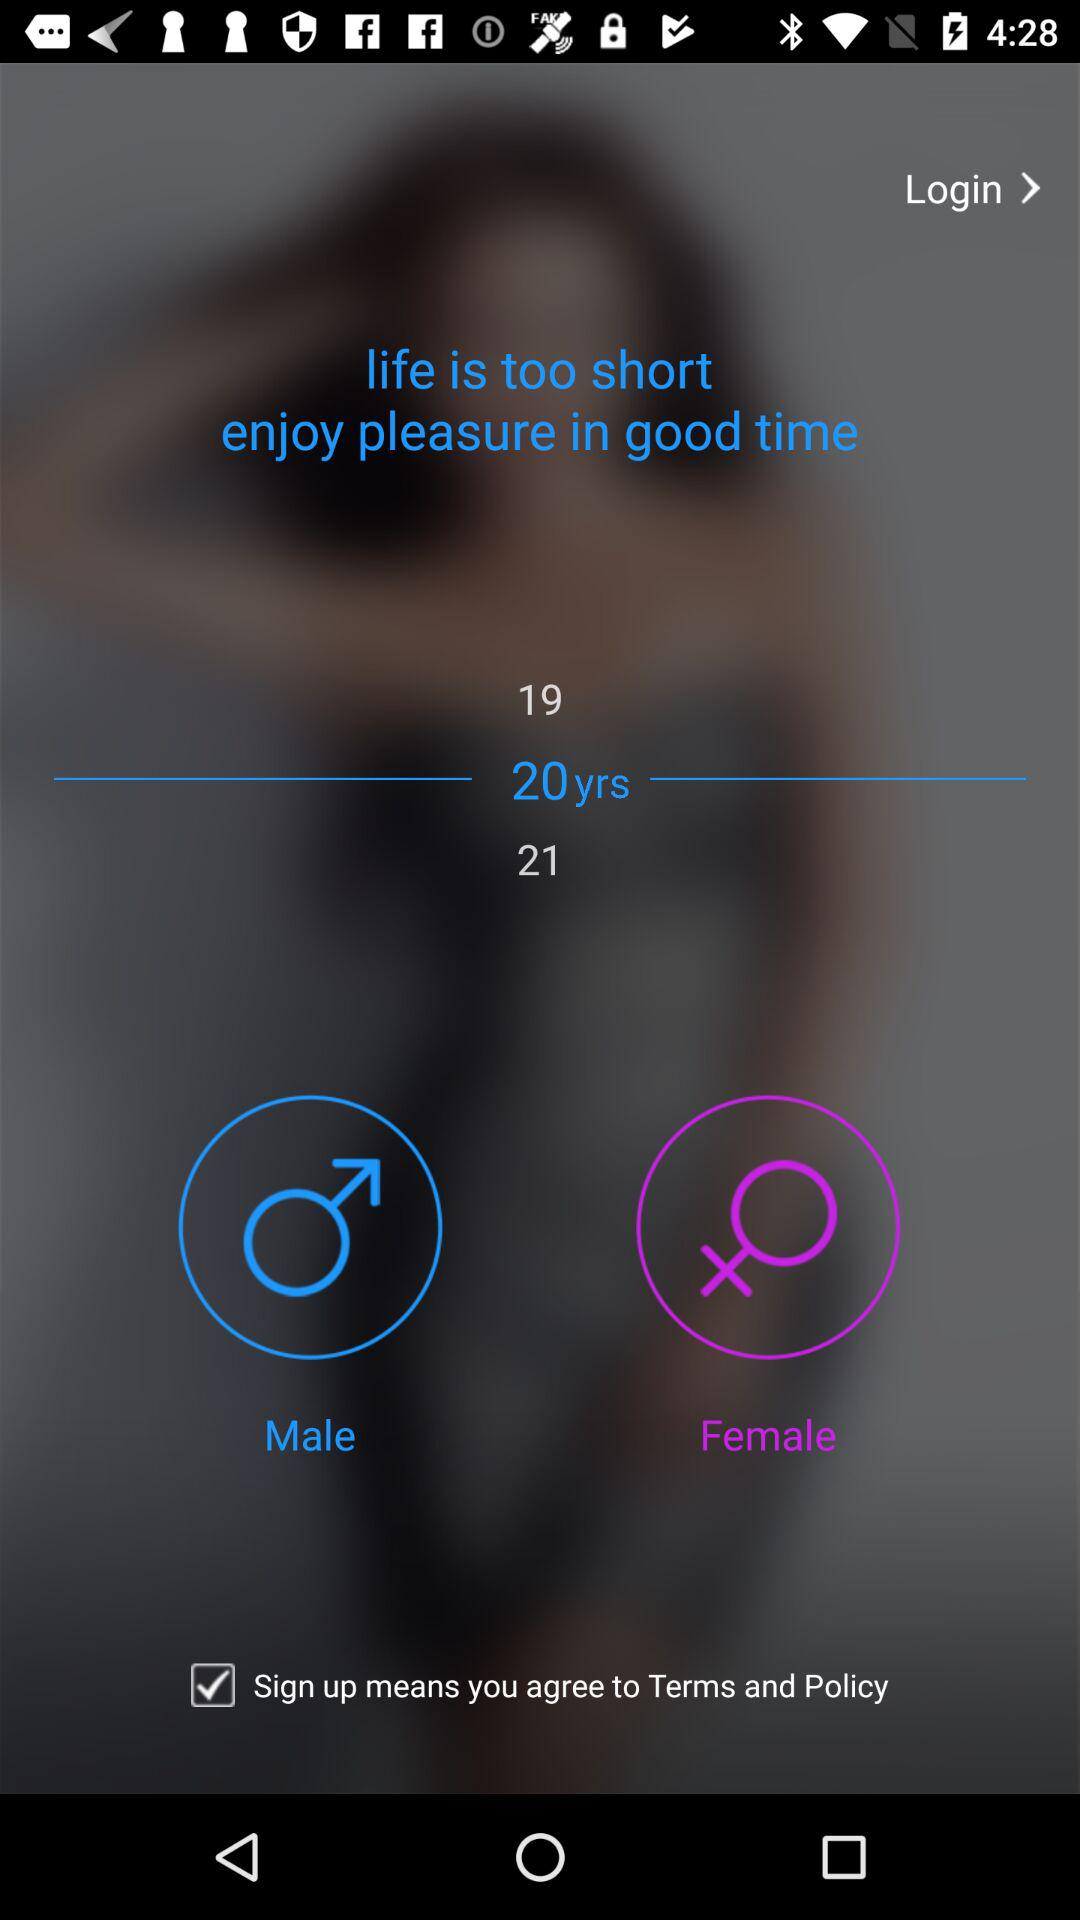What is the selected age? The selected age is 20 years. 